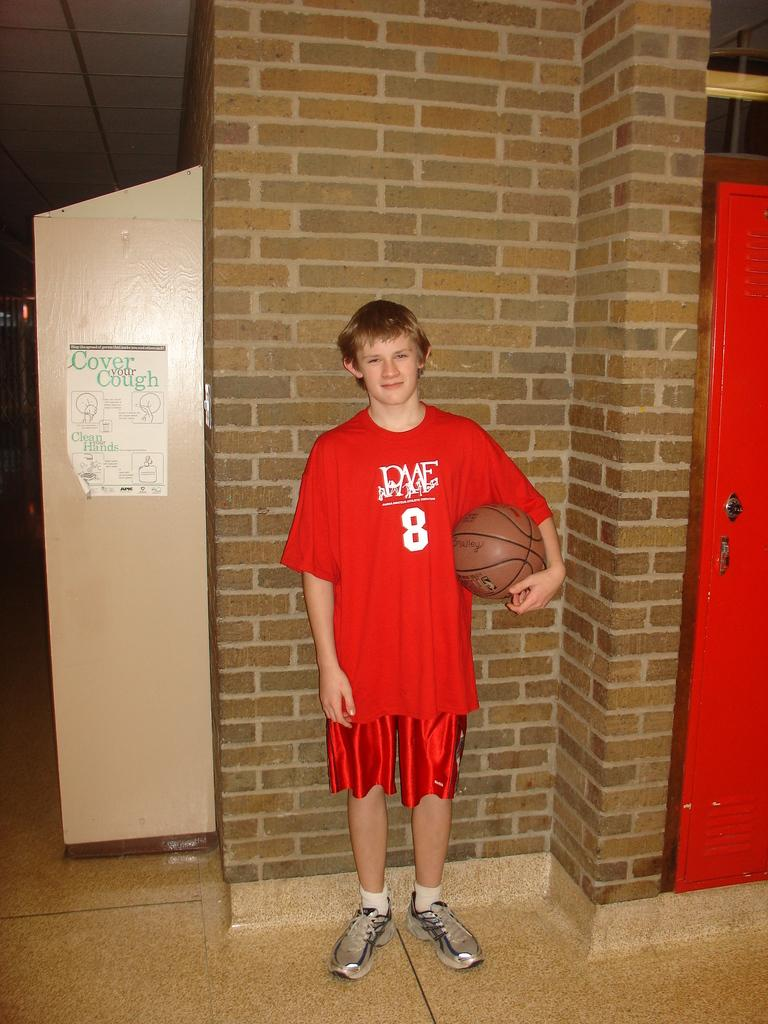<image>
Provide a brief description of the given image. A possible teenager standing against the wall wearing a basketball jersey with the number 8 on it 